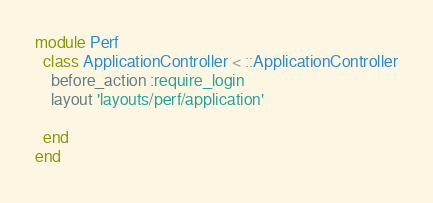<code> <loc_0><loc_0><loc_500><loc_500><_Ruby_>module Perf
  class ApplicationController < ::ApplicationController
    before_action :require_login
    layout 'layouts/perf/application'

  end
end
</code> 